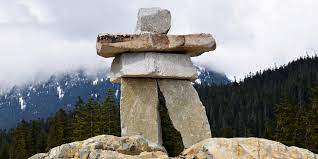What is this photo about? This photograph features an Inukshuk, a traditional stone structure built by the Inuit people of the Arctic. These structures are often found in inhospitable and stark landscapes as navigational aids, hunting grounds markers, or as a point of reference. The Inukshuk in the image is strategically positioned with a picturesque backdrop of densely forested mountains and snow-dusted peaks. The composition seems to symbolize resilience and guidance amidst harsh environments. Such landmarks bear significant cultural importance, symbolizing unity, cooperation, and human spirit. The visual perspective given from below enhances the symbolic stature of the Inukshuk, positioning it as a formidable yet serene sentinel within the wild Canadian landscape. 